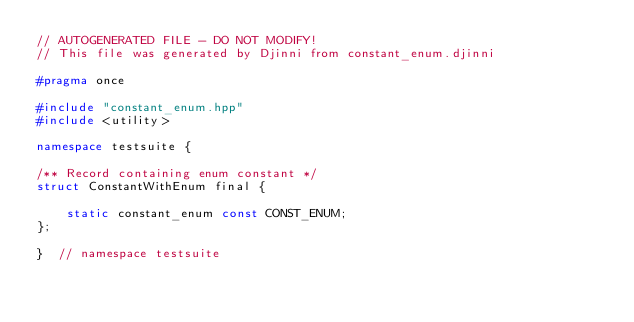<code> <loc_0><loc_0><loc_500><loc_500><_C++_>// AUTOGENERATED FILE - DO NOT MODIFY!
// This file was generated by Djinni from constant_enum.djinni

#pragma once

#include "constant_enum.hpp"
#include <utility>

namespace testsuite {

/** Record containing enum constant */
struct ConstantWithEnum final {

    static constant_enum const CONST_ENUM;
};

}  // namespace testsuite
</code> 